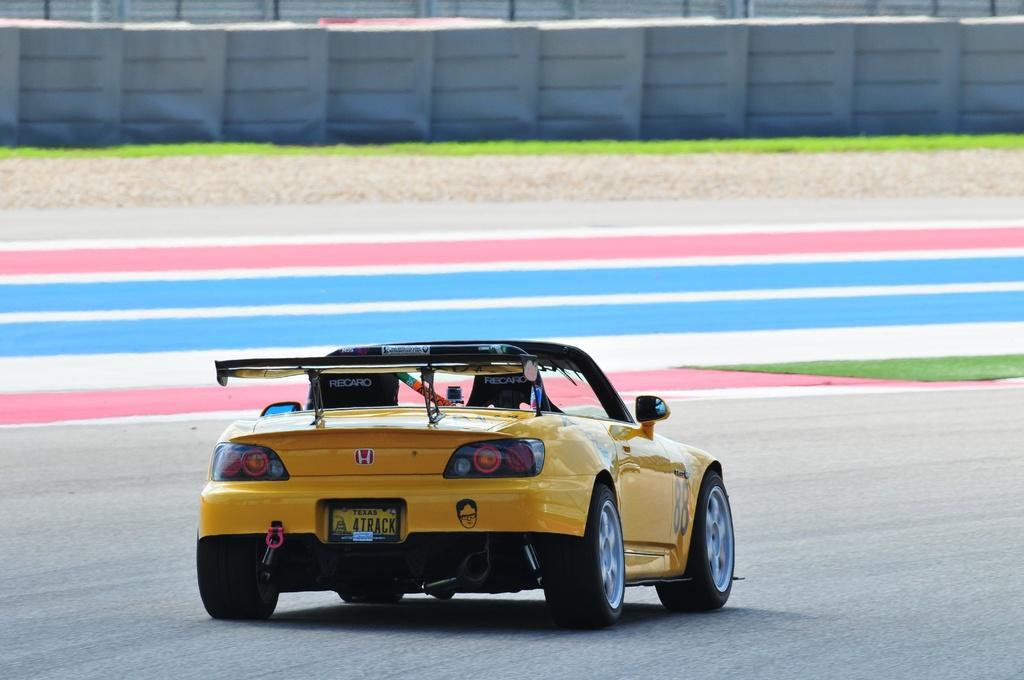Can you describe this image briefly? In this image I can see yellow and black color car on the road. Back I can see a colorful floor and ash fencing. 